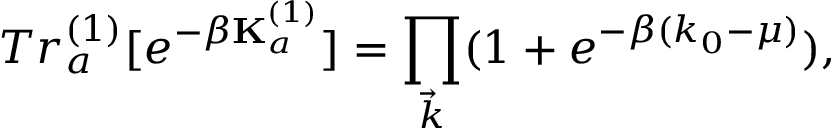Convert formula to latex. <formula><loc_0><loc_0><loc_500><loc_500>T r _ { a } ^ { ( 1 ) } [ e ^ { - \beta { K } _ { a } ^ { ( 1 ) } } ] = \prod _ { \vec { k } } ( 1 + e ^ { - \beta ( k _ { 0 } - \mu ) } ) ,</formula> 